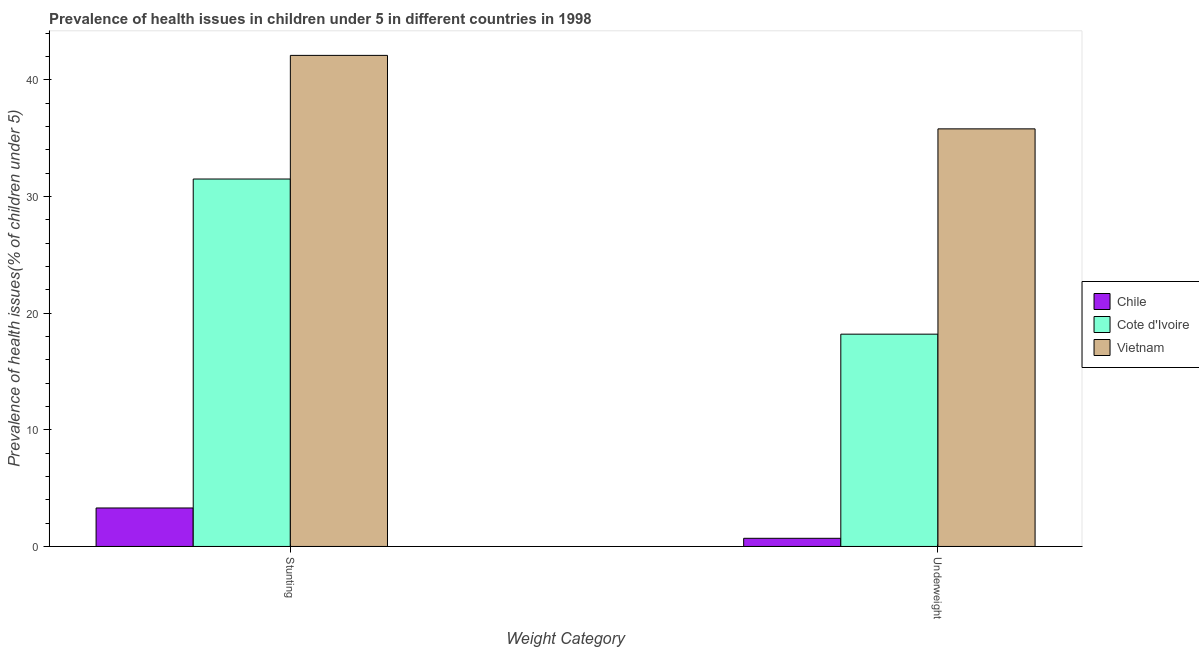How many groups of bars are there?
Your answer should be compact. 2. Are the number of bars per tick equal to the number of legend labels?
Keep it short and to the point. Yes. Are the number of bars on each tick of the X-axis equal?
Your answer should be very brief. Yes. What is the label of the 1st group of bars from the left?
Offer a terse response. Stunting. What is the percentage of underweight children in Chile?
Offer a terse response. 0.7. Across all countries, what is the maximum percentage of stunted children?
Your answer should be very brief. 42.1. Across all countries, what is the minimum percentage of stunted children?
Make the answer very short. 3.3. In which country was the percentage of stunted children maximum?
Give a very brief answer. Vietnam. In which country was the percentage of stunted children minimum?
Offer a very short reply. Chile. What is the total percentage of underweight children in the graph?
Ensure brevity in your answer.  54.7. What is the difference between the percentage of underweight children in Vietnam and that in Cote d'Ivoire?
Your answer should be very brief. 17.6. What is the difference between the percentage of stunted children in Vietnam and the percentage of underweight children in Cote d'Ivoire?
Keep it short and to the point. 23.9. What is the average percentage of stunted children per country?
Your answer should be compact. 25.63. What is the difference between the percentage of underweight children and percentage of stunted children in Cote d'Ivoire?
Offer a very short reply. -13.3. What is the ratio of the percentage of stunted children in Cote d'Ivoire to that in Chile?
Offer a very short reply. 9.55. In how many countries, is the percentage of stunted children greater than the average percentage of stunted children taken over all countries?
Give a very brief answer. 2. What does the 3rd bar from the right in Stunting represents?
Keep it short and to the point. Chile. How many bars are there?
Your response must be concise. 6. Are all the bars in the graph horizontal?
Provide a succinct answer. No. Are the values on the major ticks of Y-axis written in scientific E-notation?
Offer a terse response. No. Does the graph contain grids?
Make the answer very short. No. How many legend labels are there?
Your response must be concise. 3. How are the legend labels stacked?
Give a very brief answer. Vertical. What is the title of the graph?
Provide a succinct answer. Prevalence of health issues in children under 5 in different countries in 1998. What is the label or title of the X-axis?
Provide a short and direct response. Weight Category. What is the label or title of the Y-axis?
Your answer should be compact. Prevalence of health issues(% of children under 5). What is the Prevalence of health issues(% of children under 5) in Chile in Stunting?
Offer a terse response. 3.3. What is the Prevalence of health issues(% of children under 5) of Cote d'Ivoire in Stunting?
Make the answer very short. 31.5. What is the Prevalence of health issues(% of children under 5) in Vietnam in Stunting?
Keep it short and to the point. 42.1. What is the Prevalence of health issues(% of children under 5) in Chile in Underweight?
Your answer should be very brief. 0.7. What is the Prevalence of health issues(% of children under 5) in Cote d'Ivoire in Underweight?
Provide a short and direct response. 18.2. What is the Prevalence of health issues(% of children under 5) in Vietnam in Underweight?
Your response must be concise. 35.8. Across all Weight Category, what is the maximum Prevalence of health issues(% of children under 5) of Chile?
Your response must be concise. 3.3. Across all Weight Category, what is the maximum Prevalence of health issues(% of children under 5) in Cote d'Ivoire?
Give a very brief answer. 31.5. Across all Weight Category, what is the maximum Prevalence of health issues(% of children under 5) in Vietnam?
Your answer should be compact. 42.1. Across all Weight Category, what is the minimum Prevalence of health issues(% of children under 5) in Chile?
Provide a succinct answer. 0.7. Across all Weight Category, what is the minimum Prevalence of health issues(% of children under 5) of Cote d'Ivoire?
Keep it short and to the point. 18.2. Across all Weight Category, what is the minimum Prevalence of health issues(% of children under 5) of Vietnam?
Your answer should be compact. 35.8. What is the total Prevalence of health issues(% of children under 5) of Cote d'Ivoire in the graph?
Keep it short and to the point. 49.7. What is the total Prevalence of health issues(% of children under 5) of Vietnam in the graph?
Offer a very short reply. 77.9. What is the difference between the Prevalence of health issues(% of children under 5) of Chile in Stunting and that in Underweight?
Your response must be concise. 2.6. What is the difference between the Prevalence of health issues(% of children under 5) of Cote d'Ivoire in Stunting and that in Underweight?
Give a very brief answer. 13.3. What is the difference between the Prevalence of health issues(% of children under 5) of Chile in Stunting and the Prevalence of health issues(% of children under 5) of Cote d'Ivoire in Underweight?
Offer a very short reply. -14.9. What is the difference between the Prevalence of health issues(% of children under 5) of Chile in Stunting and the Prevalence of health issues(% of children under 5) of Vietnam in Underweight?
Offer a terse response. -32.5. What is the average Prevalence of health issues(% of children under 5) of Chile per Weight Category?
Your response must be concise. 2. What is the average Prevalence of health issues(% of children under 5) of Cote d'Ivoire per Weight Category?
Your answer should be very brief. 24.85. What is the average Prevalence of health issues(% of children under 5) in Vietnam per Weight Category?
Your response must be concise. 38.95. What is the difference between the Prevalence of health issues(% of children under 5) of Chile and Prevalence of health issues(% of children under 5) of Cote d'Ivoire in Stunting?
Your answer should be very brief. -28.2. What is the difference between the Prevalence of health issues(% of children under 5) of Chile and Prevalence of health issues(% of children under 5) of Vietnam in Stunting?
Make the answer very short. -38.8. What is the difference between the Prevalence of health issues(% of children under 5) in Cote d'Ivoire and Prevalence of health issues(% of children under 5) in Vietnam in Stunting?
Offer a very short reply. -10.6. What is the difference between the Prevalence of health issues(% of children under 5) in Chile and Prevalence of health issues(% of children under 5) in Cote d'Ivoire in Underweight?
Provide a succinct answer. -17.5. What is the difference between the Prevalence of health issues(% of children under 5) of Chile and Prevalence of health issues(% of children under 5) of Vietnam in Underweight?
Your answer should be compact. -35.1. What is the difference between the Prevalence of health issues(% of children under 5) in Cote d'Ivoire and Prevalence of health issues(% of children under 5) in Vietnam in Underweight?
Your response must be concise. -17.6. What is the ratio of the Prevalence of health issues(% of children under 5) of Chile in Stunting to that in Underweight?
Ensure brevity in your answer.  4.71. What is the ratio of the Prevalence of health issues(% of children under 5) in Cote d'Ivoire in Stunting to that in Underweight?
Keep it short and to the point. 1.73. What is the ratio of the Prevalence of health issues(% of children under 5) in Vietnam in Stunting to that in Underweight?
Offer a very short reply. 1.18. What is the difference between the highest and the second highest Prevalence of health issues(% of children under 5) of Cote d'Ivoire?
Provide a short and direct response. 13.3. What is the difference between the highest and the lowest Prevalence of health issues(% of children under 5) of Cote d'Ivoire?
Your answer should be very brief. 13.3. What is the difference between the highest and the lowest Prevalence of health issues(% of children under 5) in Vietnam?
Your response must be concise. 6.3. 